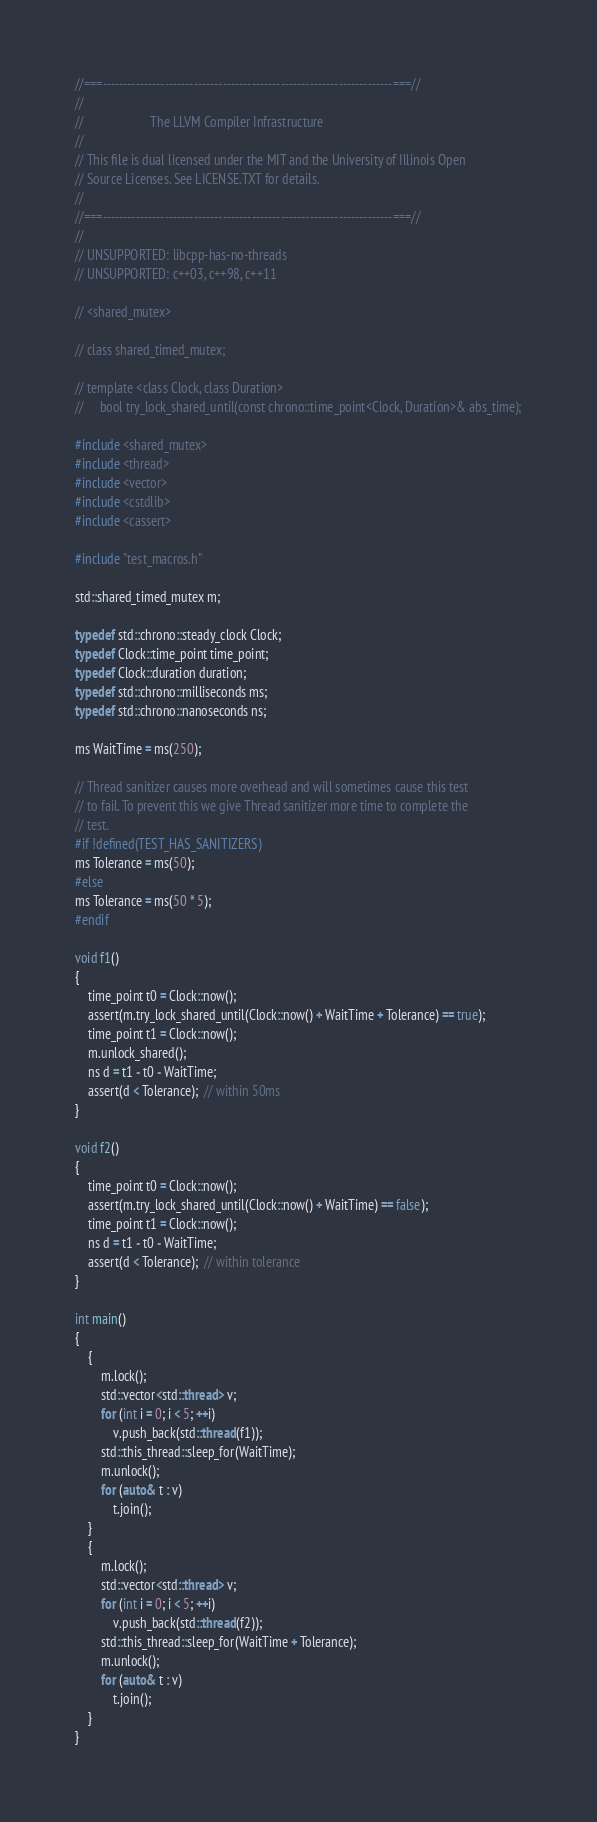<code> <loc_0><loc_0><loc_500><loc_500><_C++_>//===----------------------------------------------------------------------===//
//
//                     The LLVM Compiler Infrastructure
//
// This file is dual licensed under the MIT and the University of Illinois Open
// Source Licenses. See LICENSE.TXT for details.
//
//===----------------------------------------------------------------------===//
//
// UNSUPPORTED: libcpp-has-no-threads
// UNSUPPORTED: c++03, c++98, c++11

// <shared_mutex>

// class shared_timed_mutex;

// template <class Clock, class Duration>
//     bool try_lock_shared_until(const chrono::time_point<Clock, Duration>& abs_time);

#include <shared_mutex>
#include <thread>
#include <vector>
#include <cstdlib>
#include <cassert>

#include "test_macros.h"

std::shared_timed_mutex m;

typedef std::chrono::steady_clock Clock;
typedef Clock::time_point time_point;
typedef Clock::duration duration;
typedef std::chrono::milliseconds ms;
typedef std::chrono::nanoseconds ns;

ms WaitTime = ms(250);

// Thread sanitizer causes more overhead and will sometimes cause this test
// to fail. To prevent this we give Thread sanitizer more time to complete the
// test.
#if !defined(TEST_HAS_SANITIZERS)
ms Tolerance = ms(50);
#else
ms Tolerance = ms(50 * 5);
#endif

void f1()
{
    time_point t0 = Clock::now();
    assert(m.try_lock_shared_until(Clock::now() + WaitTime + Tolerance) == true);
    time_point t1 = Clock::now();
    m.unlock_shared();
    ns d = t1 - t0 - WaitTime;
    assert(d < Tolerance);  // within 50ms
}

void f2()
{
    time_point t0 = Clock::now();
    assert(m.try_lock_shared_until(Clock::now() + WaitTime) == false);
    time_point t1 = Clock::now();
    ns d = t1 - t0 - WaitTime;
    assert(d < Tolerance);  // within tolerance
}

int main()
{
    {
        m.lock();
        std::vector<std::thread> v;
        for (int i = 0; i < 5; ++i)
            v.push_back(std::thread(f1));
        std::this_thread::sleep_for(WaitTime);
        m.unlock();
        for (auto& t : v)
            t.join();
    }
    {
        m.lock();
        std::vector<std::thread> v;
        for (int i = 0; i < 5; ++i)
            v.push_back(std::thread(f2));
        std::this_thread::sleep_for(WaitTime + Tolerance);
        m.unlock();
        for (auto& t : v)
            t.join();
    }
}
</code> 